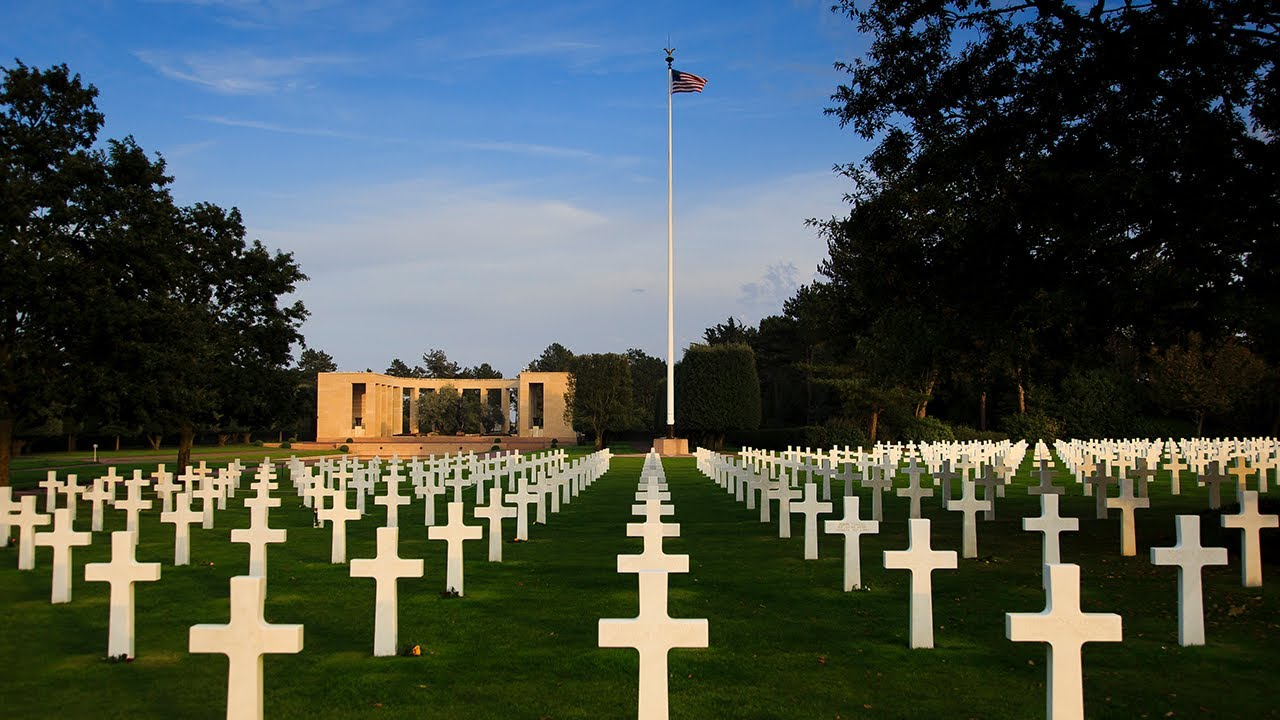What do you think is going on in this snapshot? This image shows the American Cemetery at Omaha Beach in Normandy, France. It is a powerful and sobering reminder of the immense sacrifices made during the D-Day invasions on June 6, 1944, during World War II. Here, the neat rows of white crosses, each representing a fallen American soldier, stretch towards the horizon under a serene blue sky. This solemn scene is not just a graveyard but a memorial and a place for reflection on the costs of war and the price of freedom, symbolized by the American flag flying at half-mast in the distance. 